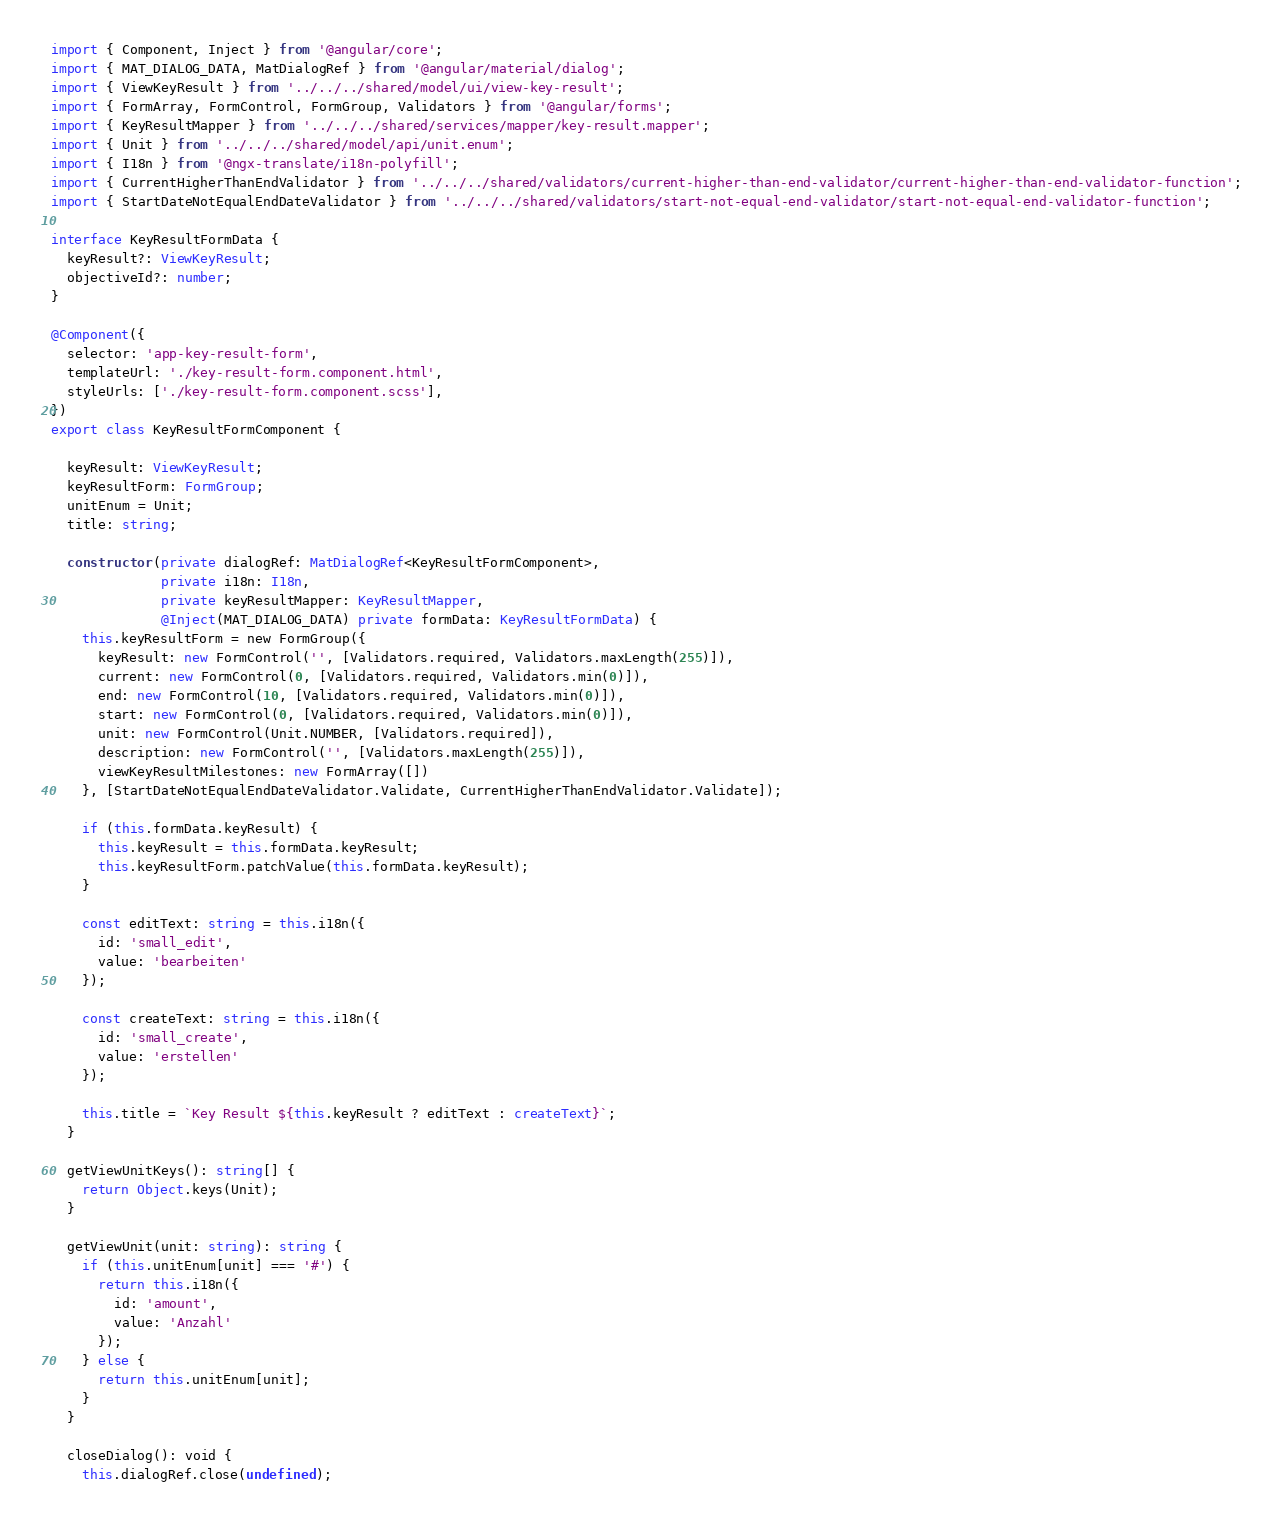<code> <loc_0><loc_0><loc_500><loc_500><_TypeScript_>import { Component, Inject } from '@angular/core';
import { MAT_DIALOG_DATA, MatDialogRef } from '@angular/material/dialog';
import { ViewKeyResult } from '../../../shared/model/ui/view-key-result';
import { FormArray, FormControl, FormGroup, Validators } from '@angular/forms';
import { KeyResultMapper } from '../../../shared/services/mapper/key-result.mapper';
import { Unit } from '../../../shared/model/api/unit.enum';
import { I18n } from '@ngx-translate/i18n-polyfill';
import { CurrentHigherThanEndValidator } from '../../../shared/validators/current-higher-than-end-validator/current-higher-than-end-validator-function';
import { StartDateNotEqualEndDateValidator } from '../../../shared/validators/start-not-equal-end-validator/start-not-equal-end-validator-function';

interface KeyResultFormData {
  keyResult?: ViewKeyResult;
  objectiveId?: number;
}

@Component({
  selector: 'app-key-result-form',
  templateUrl: './key-result-form.component.html',
  styleUrls: ['./key-result-form.component.scss'],
})
export class KeyResultFormComponent {

  keyResult: ViewKeyResult;
  keyResultForm: FormGroup;
  unitEnum = Unit;
  title: string;

  constructor(private dialogRef: MatDialogRef<KeyResultFormComponent>,
              private i18n: I18n,
              private keyResultMapper: KeyResultMapper,
              @Inject(MAT_DIALOG_DATA) private formData: KeyResultFormData) {
    this.keyResultForm = new FormGroup({
      keyResult: new FormControl('', [Validators.required, Validators.maxLength(255)]),
      current: new FormControl(0, [Validators.required, Validators.min(0)]),
      end: new FormControl(10, [Validators.required, Validators.min(0)]),
      start: new FormControl(0, [Validators.required, Validators.min(0)]),
      unit: new FormControl(Unit.NUMBER, [Validators.required]),
      description: new FormControl('', [Validators.maxLength(255)]),
      viewKeyResultMilestones: new FormArray([])
    }, [StartDateNotEqualEndDateValidator.Validate, CurrentHigherThanEndValidator.Validate]);

    if (this.formData.keyResult) {
      this.keyResult = this.formData.keyResult;
      this.keyResultForm.patchValue(this.formData.keyResult);
    }

    const editText: string = this.i18n({
      id: 'small_edit',
      value: 'bearbeiten'
    });

    const createText: string = this.i18n({
      id: 'small_create',
      value: 'erstellen'
    });

    this.title = `Key Result ${this.keyResult ? editText : createText}`;
  }

  getViewUnitKeys(): string[] {
    return Object.keys(Unit);
  }

  getViewUnit(unit: string): string {
    if (this.unitEnum[unit] === '#') {
      return this.i18n({
        id: 'amount',
        value: 'Anzahl'
      });
    } else {
      return this.unitEnum[unit];
    }
  }

  closeDialog(): void {
    this.dialogRef.close(undefined);</code> 